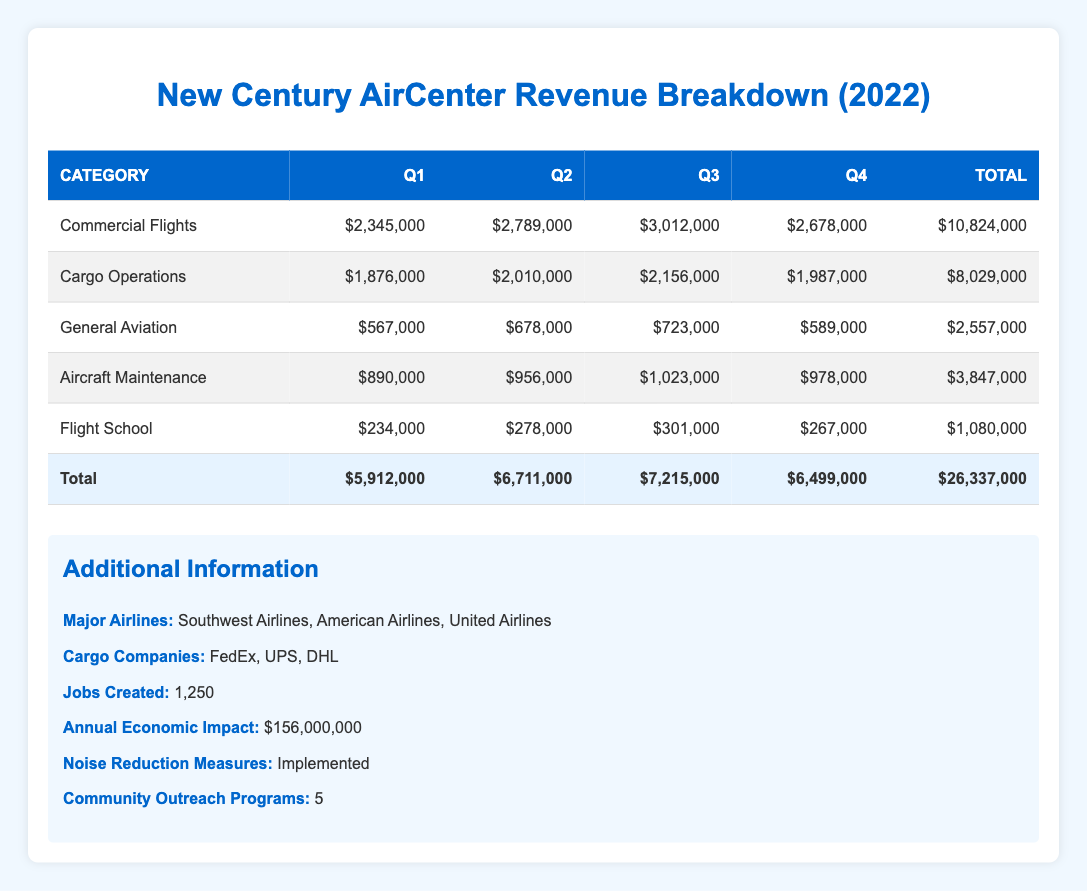What was the total revenue from commercial flights in 2022? To find the total revenue from commercial flights, we need to sum the revenue from each quarter: (2,345,000 + 2,789,000 + 3,012,000 + 2,678,000) = 10,824,000.
Answer: 10,824,000 In which quarter did general aviation have the highest revenue? Looking at the revenue figures for general aviation across the quarters, we have: Q1: 567,000, Q2: 678,000, Q3: 723,000, Q4: 589,000. The highest revenue is in Q3 with 723,000.
Answer: Q3 What is the average revenue from aircraft maintenance across all quarters? We first sum the revenues from each quarter: (890,000 + 956,000 + 1,023,000 + 978,000) = 3,847,000. Then, we divide this sum by the number of quarters (4): 3,847,000 / 4 = 961,750.
Answer: 961,750 Did cargo operations revenue decline from Q3 to Q4? We can compare the revenue figures for Q3 and Q4 for cargo operations: Q3 revenue is 2,156,000 and Q4 revenue is 1,987,000. Since 1,987,000 is less than 2,156,000, it confirms a decline.
Answer: Yes What is the total revenue from all categories in Q2? We need to sum the revenues from all categories for Q2: Commercial Flights (2,789,000) + Cargo Operations (2,010,000) + General Aviation (678,000) + Aircraft Maintenance (956,000) + Flight School (278,000) = 5,711,000.
Answer: 5,711,000 Did the total revenue for Q4 exceed total revenue for Q1? To determine this, we look at total revenue for Q4, which is 6,499,000, and total revenue for Q1, which is 5,912,000. Since 6,499,000 is greater than 5,912,000, Q4 did exceed Q1.
Answer: Yes How much revenue did the flight school generate in 2022? We sum the flight school revenue from all quarters: (234,000 + 278,000 + 301,000 + 267,000) = 1,080,000.
Answer: 1,080,000 Which category had the second highest total revenue in 2022? By summing total revenues for each category: Commercial Flights: 10,824,000, Cargo Operations: 8,029,000, General Aviation: 2,557,000, Aircraft Maintenance: 3,847,000, Flight School: 1,080,000. Cargo Operations is the second highest after Commercial Flights.
Answer: Cargo Operations 